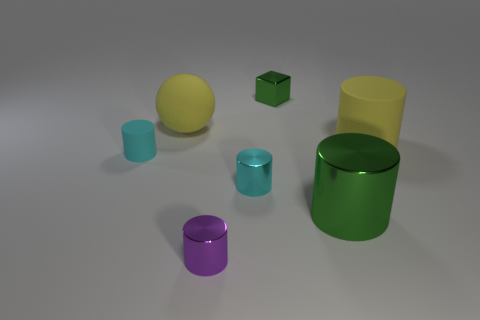Subtract all yellow cylinders. How many cylinders are left? 4 Add 3 matte cylinders. How many objects exist? 10 Subtract all purple cylinders. How many cylinders are left? 4 Subtract all spheres. How many objects are left? 6 Subtract all brown cylinders. Subtract all purple blocks. How many cylinders are left? 5 Subtract all gray blocks. How many green cylinders are left? 1 Add 1 tiny cyan metal cylinders. How many tiny cyan metal cylinders are left? 2 Add 3 shiny cylinders. How many shiny cylinders exist? 6 Subtract 0 blue cylinders. How many objects are left? 7 Subtract all tiny blue rubber spheres. Subtract all tiny cyan rubber things. How many objects are left? 6 